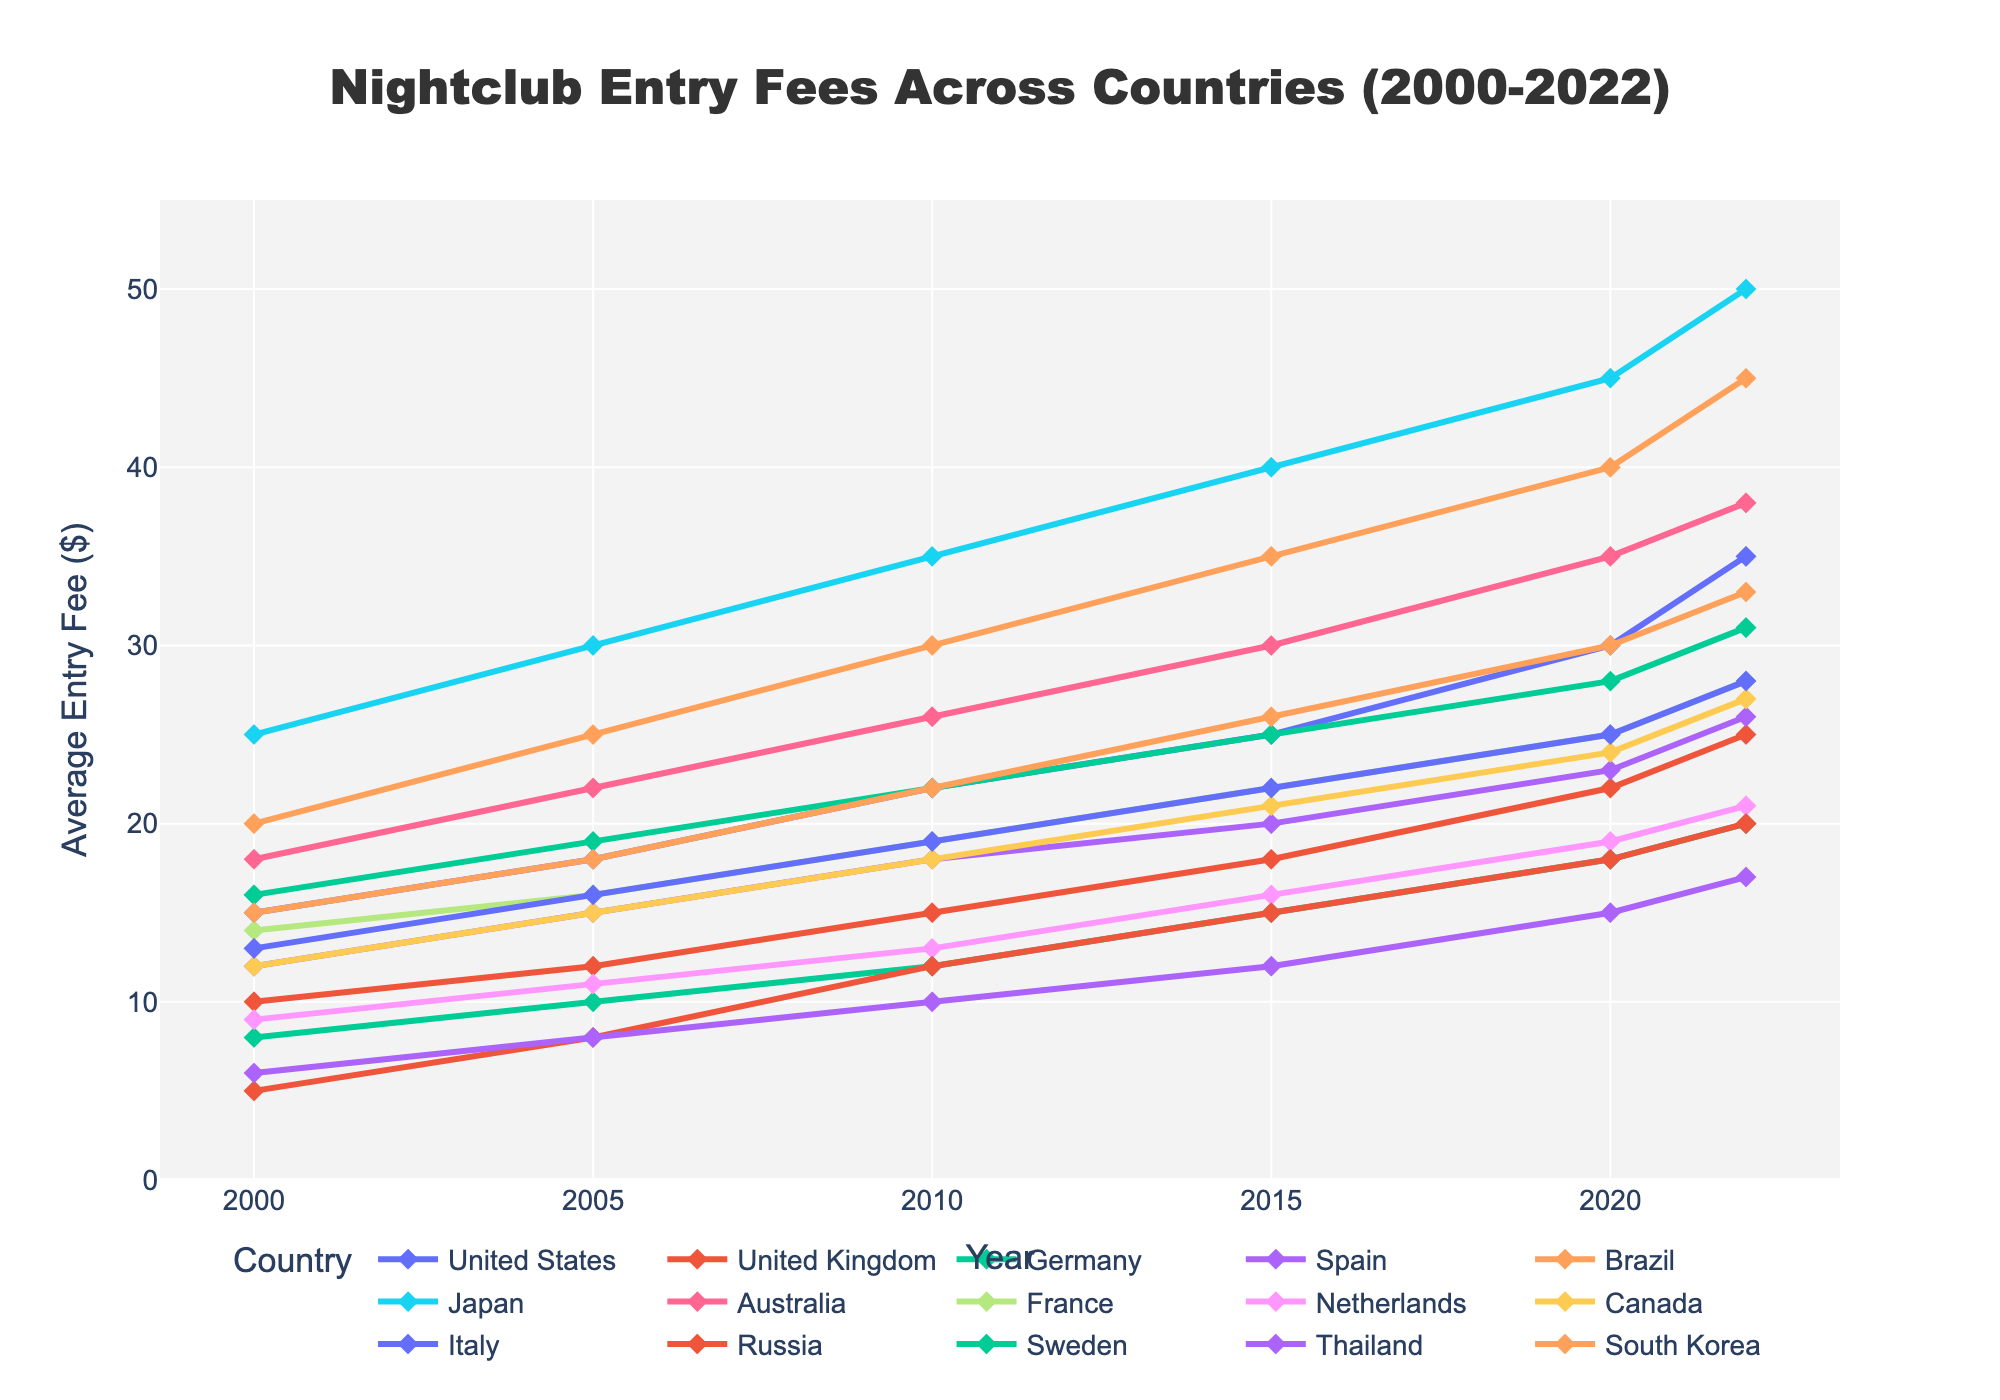What country had the highest average nightclub entry fee in 2022? By looking at the endpoint of each country's line in 2022, we see that Japan has the highest point on the y-axis, indicating the highest fee.
Answer: Japan Which country had the smallest increase in nightclub entry fees from 2000 to 2022? To find the smallest increase, compare the difference between 2022 and 2000 values for each country. Germany's fees rose from 8 in 2000 to 20 in 2022, which is the smallest increase of 12.
Answer: Germany Between Spain and Canada, which country saw a greater increase in entry fees from 2000 to 2022? Spain's fees increased from 12 (2000) to 26 (2022), a difference of 14. Canada's fees increased from 12 (2000) to 27 (2022), a difference of 15. Comparing 14 and 15, Canada had a greater increase.
Answer: Canada What is the average nightclub entry fee in the United States across all the years shown? Sum the entry fees for US: 15 + 18 + 22 + 25 + 30 + 35 = 145. There are 6 data points, so the average is 145 / 6.
Answer: 24.17 Which country had the steepest increase in nightclub entry fees around 2015? Looking at the steepest line segment around 2015, we find that Brazil’s line from 2010 to 2015 is the steepest, going from 30 to 35, an increase of 5.
Answer: Brazil From 2000 to 2005, which countries had their nightclub entry fees increased by exactly 3 units? Checking the changes from 2000 to 2005, United Kingdom (10-12), France (14-16), and Russia (5-8) all increased by 3 units.
Answer: United Kingdom, France, Russia How many countries had average nightclub entry fees less than 20 dollars in 2010? By checking the y-values for each country in 2010, we see that Germany, Netherlands, Russia, and Thailand have entry fees less than 20 dollars.
Answer: 4 What is the combined sum of nightclub entry fees in Sweden for the years 2000, 2010, and 2020? Adding Sweden's fees for those years: 16 (2000) + 22 (2010) + 28 (2020) = 66.
Answer: 66 Compare the trend of entry fees between Australia and South Korea from 2010 to 2022. From 2010 to 2022, Australia's fees increased from 26 to 38, while South Korea's fees increased from 22 to 33. Both countries show an increasing trend, but Australia's increase is by 12, and South Korea's by 11.
Answer: Australia had a slightly higher increase Which country has a relatively stable increase in nightclub entry fees over time? A relatively stable increase suggests a consistent upward trend without large fluctuations. Germany shows a smooth and steady increase from 8 in 2000 to 20 in 2022.
Answer: Germany 